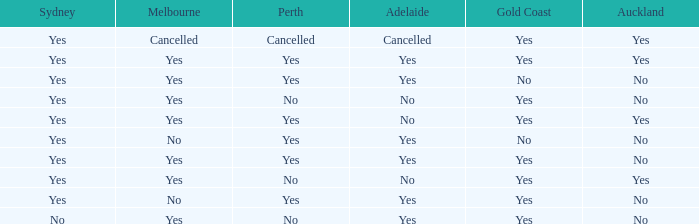In what context does sydney involve adelaide, gold coast, melbourne, and auckland, all with a positive association? Yes. 